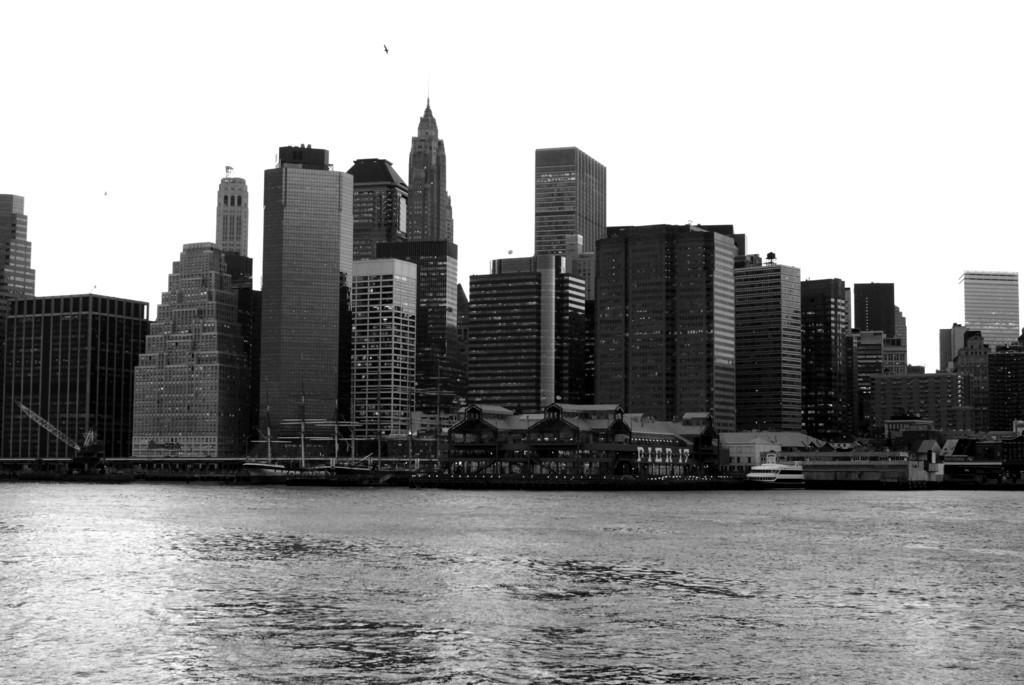Describe this image in one or two sentences. In this image, in the middle there are buildings, birds, lights, water, waves, sky. 